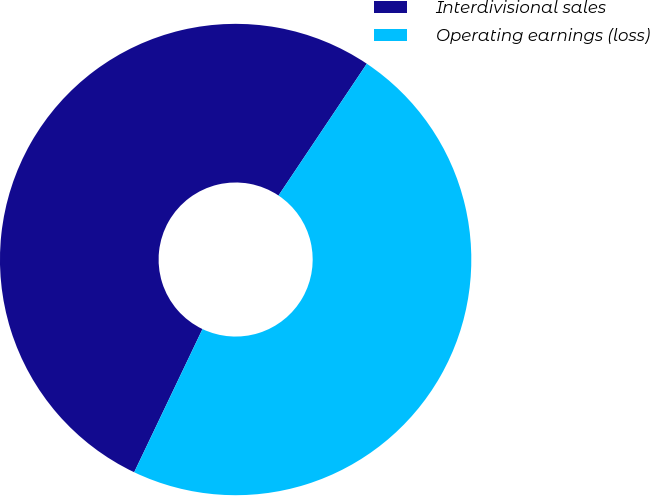<chart> <loc_0><loc_0><loc_500><loc_500><pie_chart><fcel>Interdivisional sales<fcel>Operating earnings (loss)<nl><fcel>52.31%<fcel>47.69%<nl></chart> 